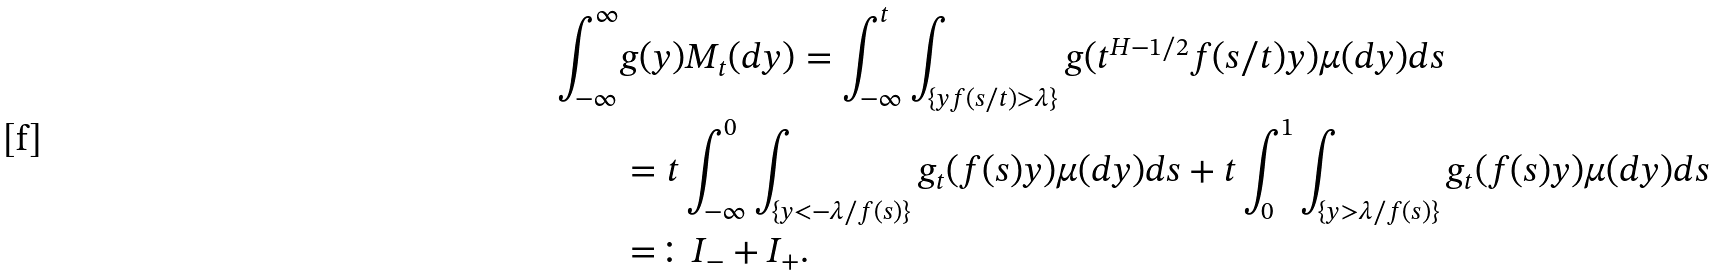<formula> <loc_0><loc_0><loc_500><loc_500>\int _ { - \infty } ^ { \infty } & g ( y ) M _ { t } ( d y ) = \int _ { - \infty } ^ { t } \int _ { \{ y f ( s / t ) > \lambda \} } g ( t ^ { H - 1 / 2 } f ( s / t ) y ) \mu ( d y ) d s \\ & = t \int _ { - \infty } ^ { 0 } \int _ { \{ y < - \lambda / f ( s ) \} } g _ { t } ( f ( s ) y ) \mu ( d y ) d s + t \int _ { 0 } ^ { 1 } \int _ { \{ y > \lambda / f ( s ) \} } g _ { t } ( f ( s ) y ) \mu ( d y ) d s \\ & = \colon I _ { - } + I _ { + } .</formula> 